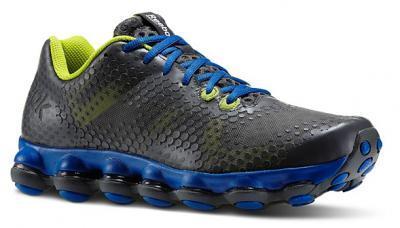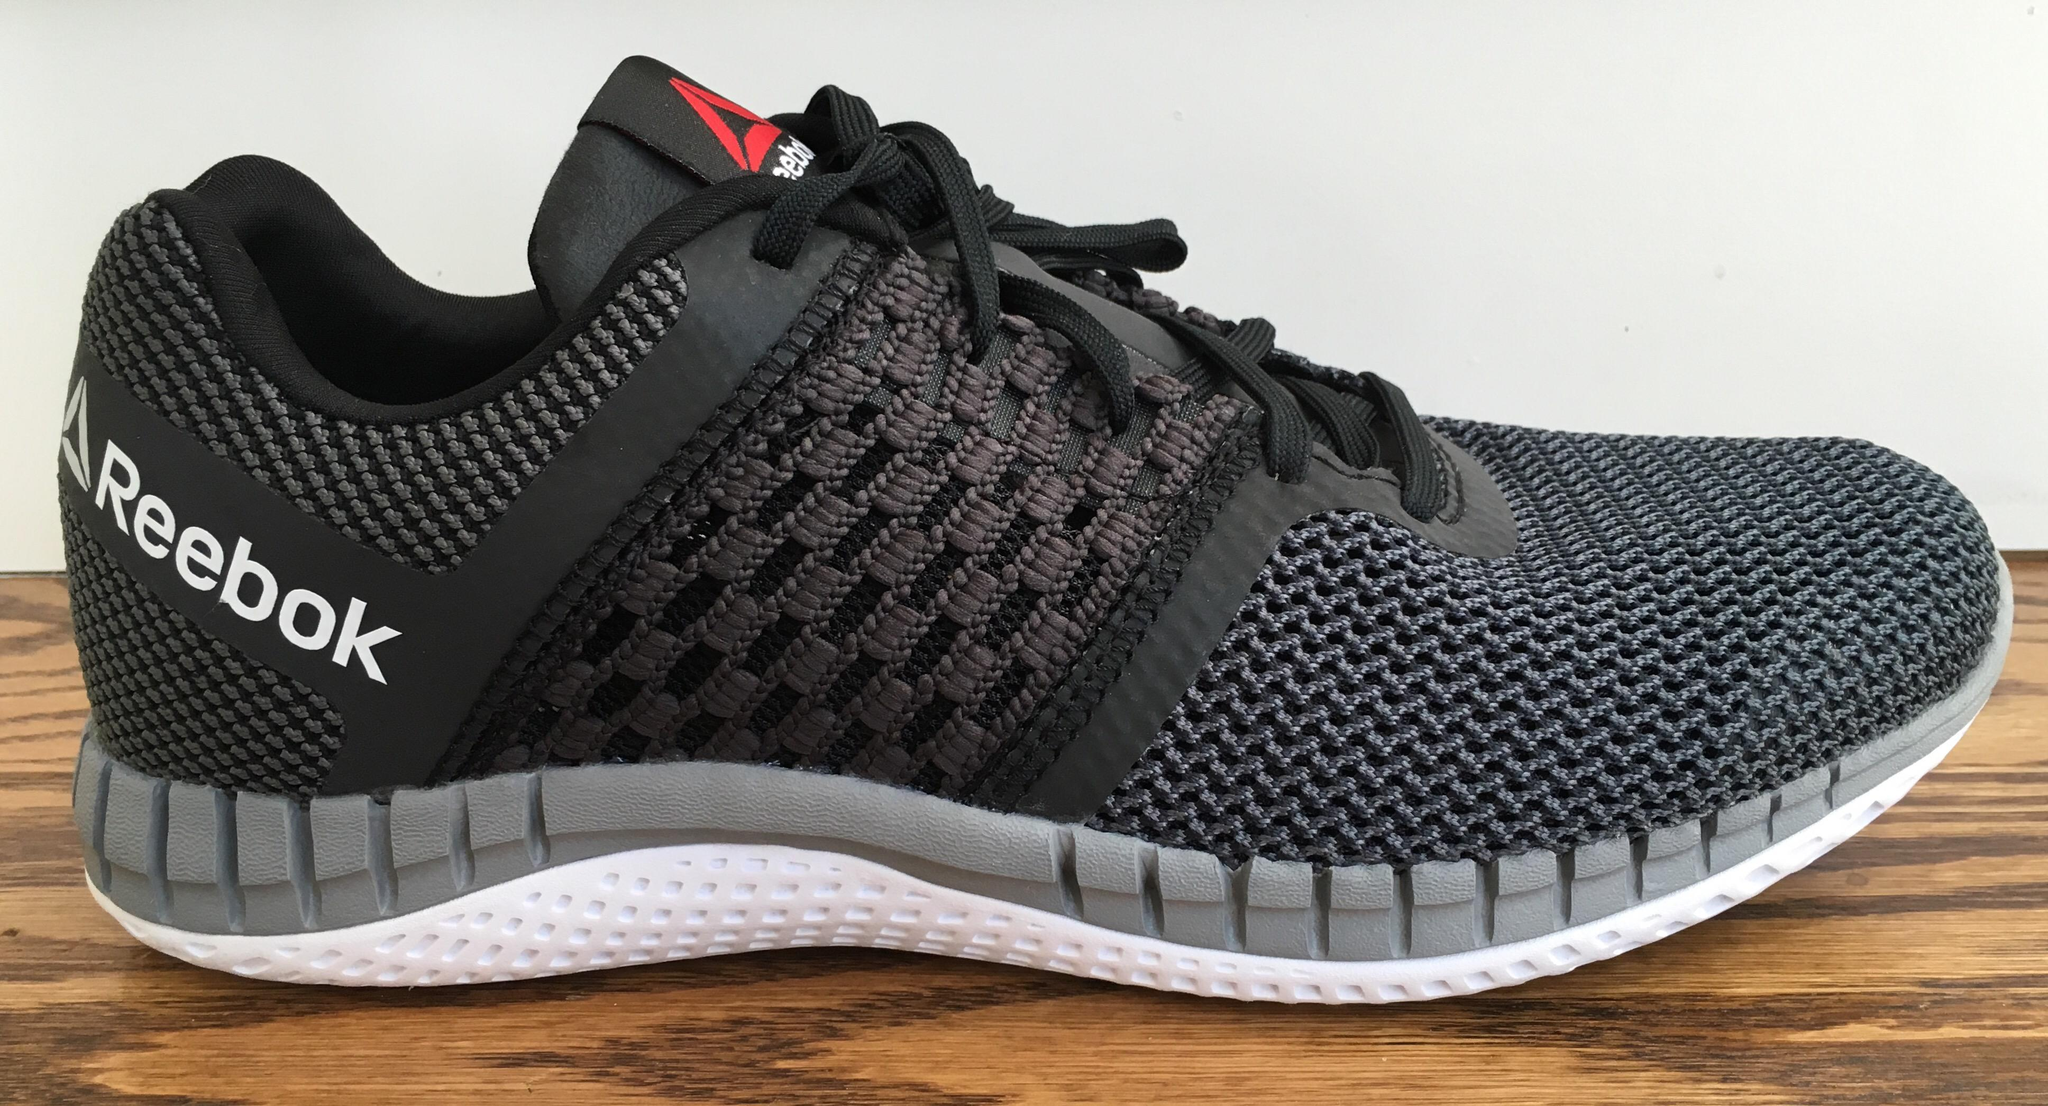The first image is the image on the left, the second image is the image on the right. Assess this claim about the two images: "The left image shows running shoes that are being worn on human feet". Correct or not? Answer yes or no. No. The first image is the image on the left, the second image is the image on the right. Examine the images to the left and right. Is the description "An image contains only one right-side-up blue sneaker with a sole that is at least partly white." accurate? Answer yes or no. No. 